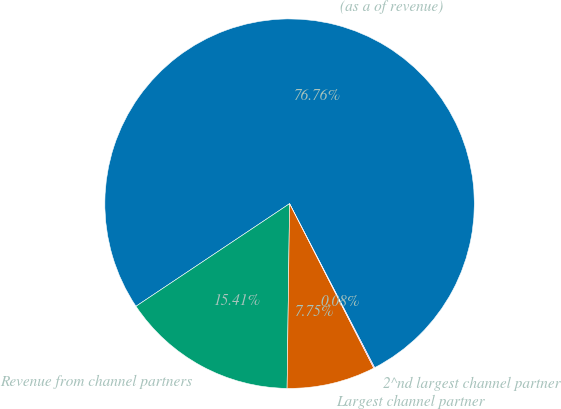Convert chart. <chart><loc_0><loc_0><loc_500><loc_500><pie_chart><fcel>(as a of revenue)<fcel>Revenue from channel partners<fcel>Largest channel partner<fcel>2^nd largest channel partner<nl><fcel>76.76%<fcel>15.41%<fcel>7.75%<fcel>0.08%<nl></chart> 